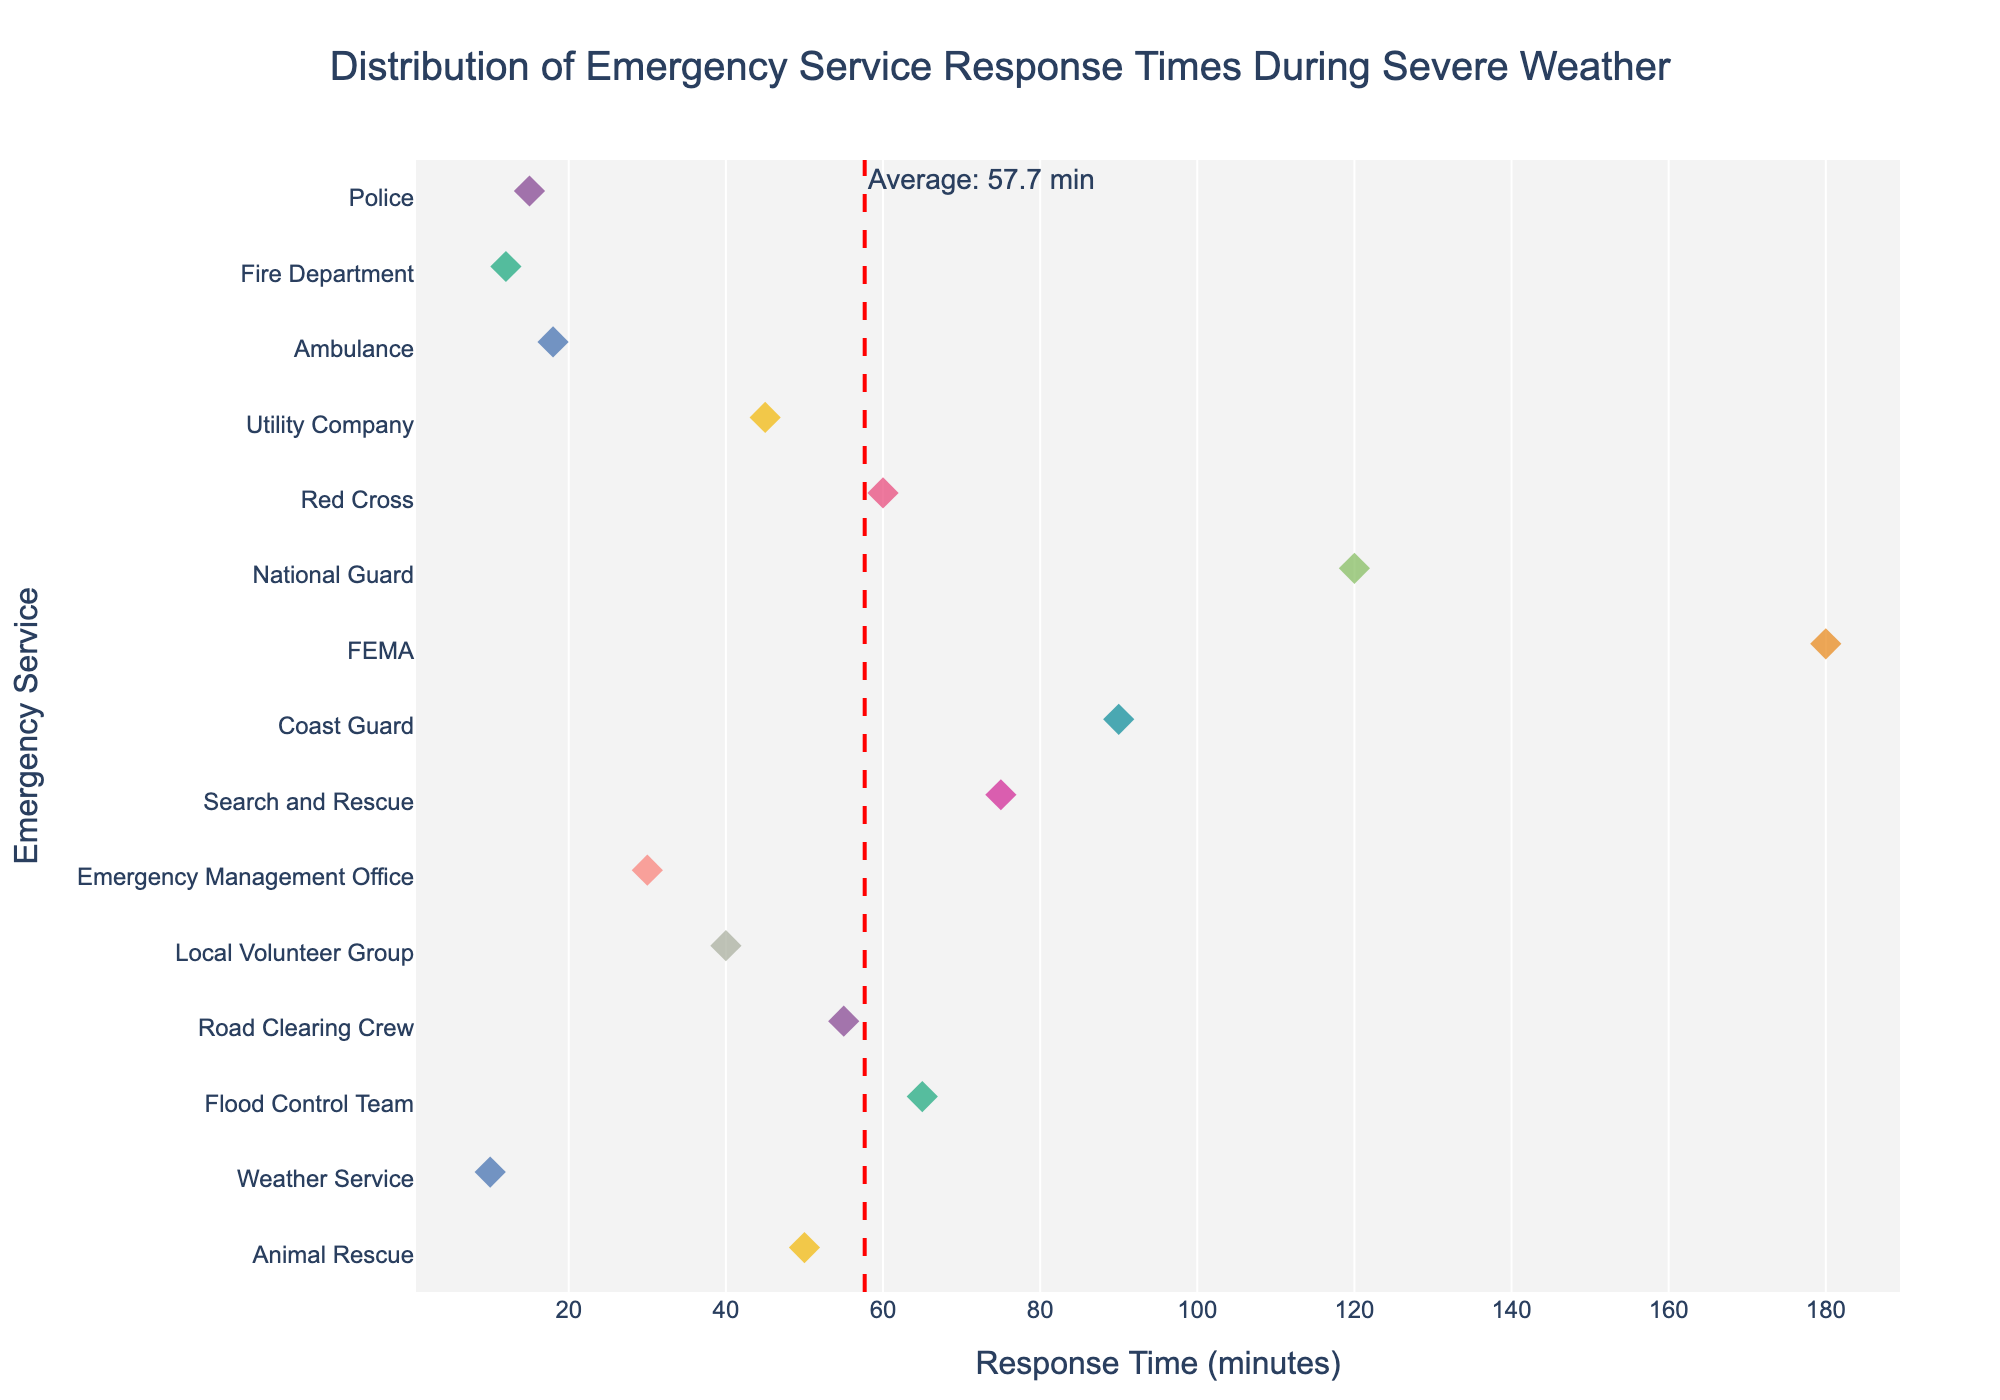What's the title of the plot? The title is usually displayed at the top of the plot. It indicates the subject matter being visualized in the graph.
Answer: Distribution of Emergency Service Response Times During Severe Weather How many emergency services are represented in the plot? Each 'Service' is a unique entity along the y-axis. Counting these will give the total number of emergency services represented.
Answer: 15 Which emergency service has the fastest response time? The emergency service with the smallest point on the x-axis represents the fastest response time. This point is on the far left of the plot.
Answer: Weather Service What is the response time for FEMA? Locate the label "FEMA" on the y-axis, then look at the corresponding point on the x-axis to find its response time.
Answer: 180 minutes What is the average response time for all services? There is a vertical line marked on the plot annotated with the average response time. This line helps to quickly identify the average value for the dataset.
Answer: Approximately 60.7 minutes Which emergency service has the longest response time? The emergency service with the largest point on the x-axis represents the longest response time. This point is on the far right of the plot.
Answer: FEMA How does the response time of the Coast Guard compare to that of the Fire Department? Locate "Coast Guard" and "Fire Department" on the y-axis. Trace forward to see their respective response times on the x-axis and compare them.
Answer: Coast Guard (90 minutes) takes longer than Fire Department (12 minutes) What is the difference in response time between the Ambulance and the Local Volunteer Group? Find the response time for "Ambulance" and "Local Volunteer Group" on the x-axis, then calculate their difference: 40 (Local Volunteer Group) - 18 (Ambulance) = 22 minutes.
Answer: 22 minutes Which services have response times above the average? Identify the vertical line showing the average response time. Then look for services whose response times, represented by points, are to the right of this line.
Answer: National Guard, FEMA, Coast Guard, Search and Rescue, Flood Control Team, Animal Rescue, Red Cross, Road Clearing Crew What can be said about the spread of data in this plot? The spread indicates the dispersion of response times across different emergency services. Observing the distribution along the x-axis can provide insights.
Answer: The response times vary widely from 10 to 180 minutes, indicating a large variability 